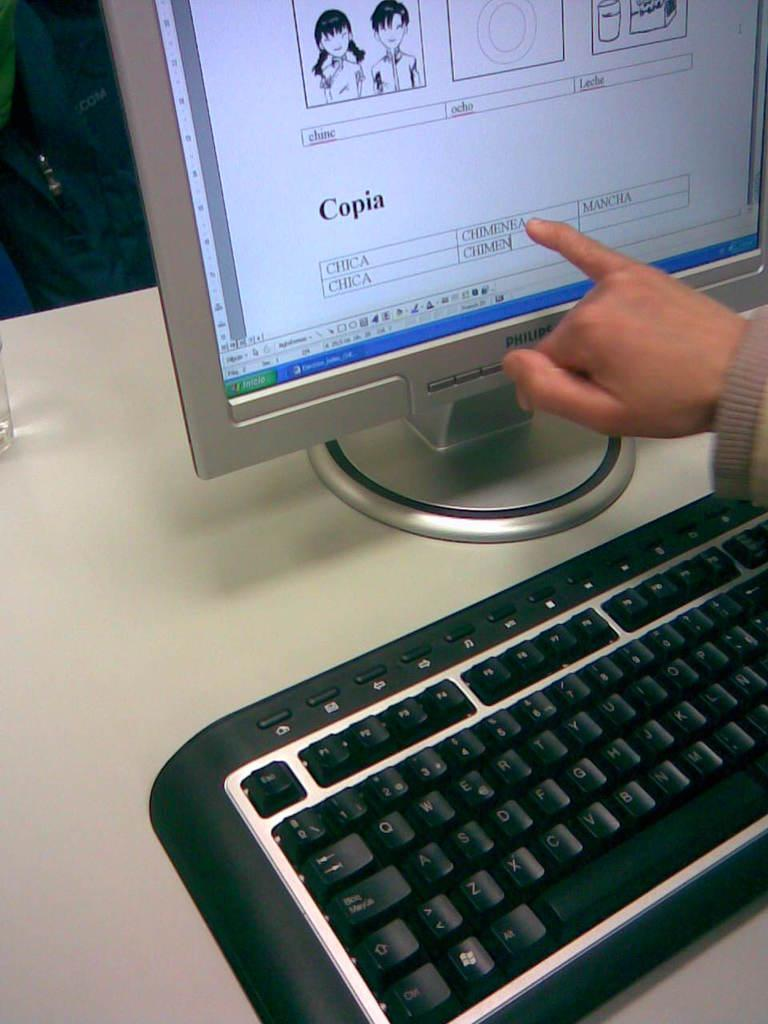<image>
Offer a succinct explanation of the picture presented. Person using their pinky to point at a Philips monitor. 